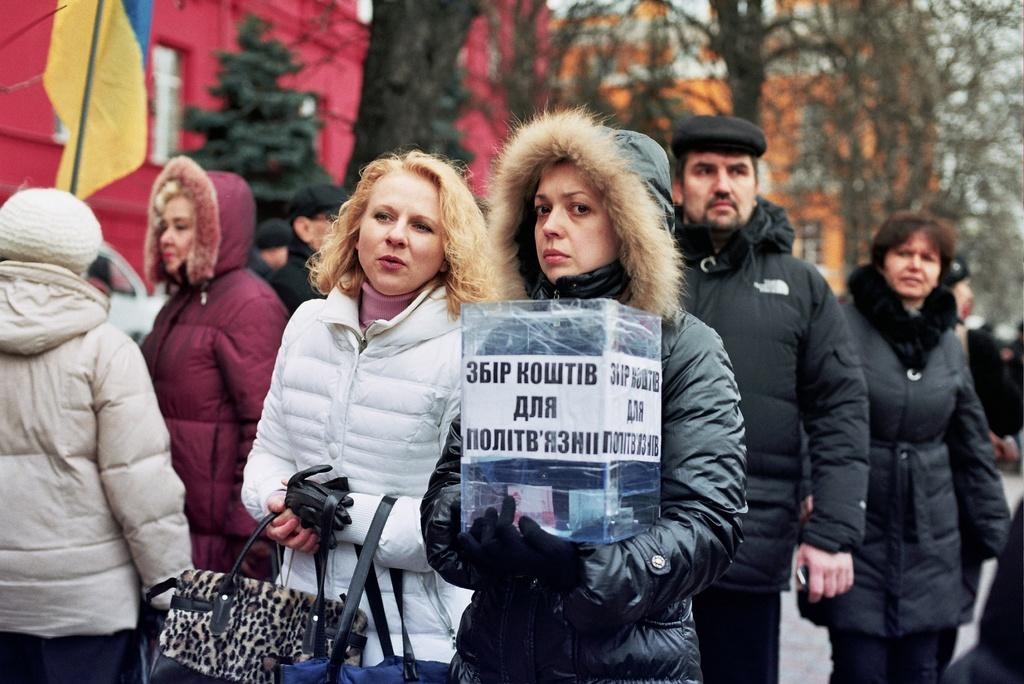What can be observed about the people in the image? There are people standing in the image, and they are wearing jackets. What is the woman holding in the image? One woman is holding a box with money, and another woman is holding bags. What additional elements can be seen in the image? There is a flag visible in the image, as well as a building and trees. What type of toothpaste is being advertised on the club in the image? There is no club or toothpaste present in the image. 